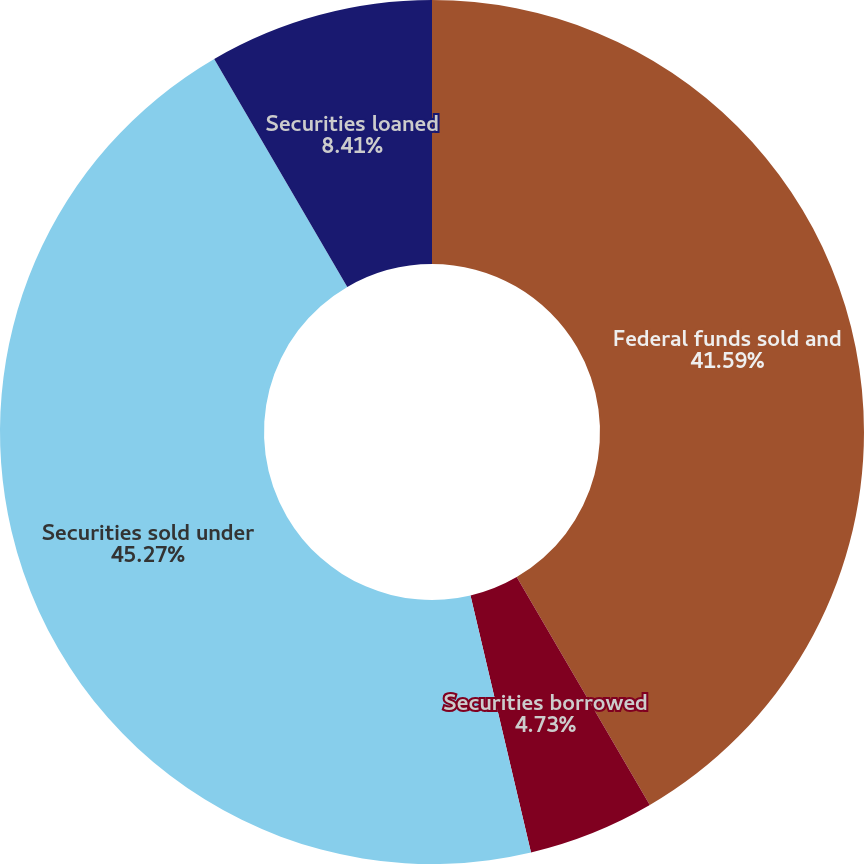Convert chart to OTSL. <chart><loc_0><loc_0><loc_500><loc_500><pie_chart><fcel>Federal funds sold and<fcel>Securities borrowed<fcel>Securities sold under<fcel>Securities loaned<nl><fcel>41.59%<fcel>4.73%<fcel>45.27%<fcel>8.41%<nl></chart> 